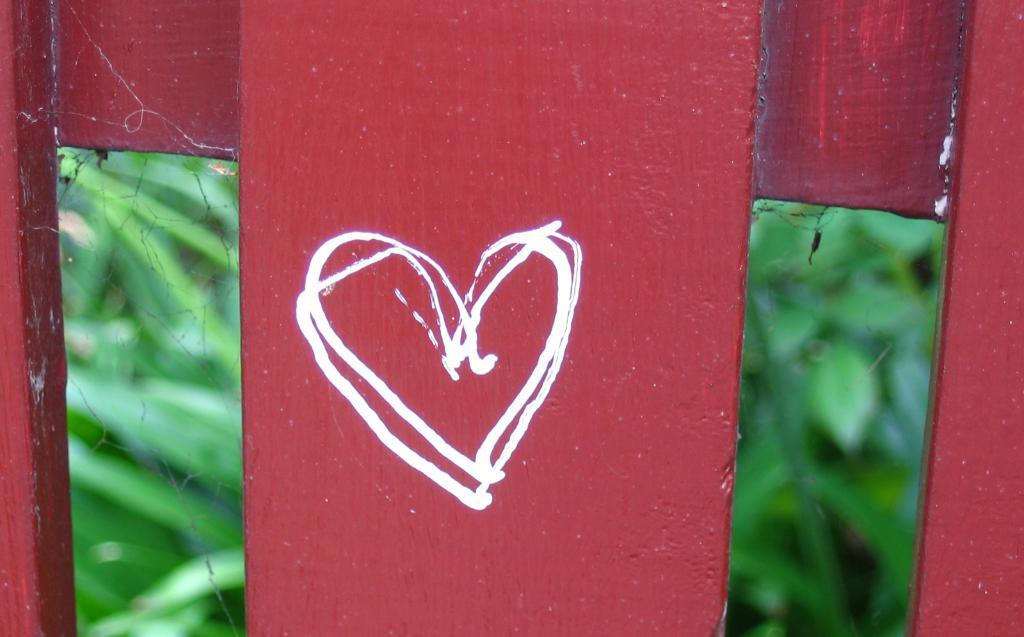What shape can be seen in the drawing in the image? There is a heart shape drawing in the image. What material is the drawing on? The drawing is on wood. Where is the drawing located in the image? The drawing is in the foreground of the image. What type of glass is being used to hold the popcorn in the image? There is no glass or popcorn present in the image; it only features a heart shape drawing on wood. 